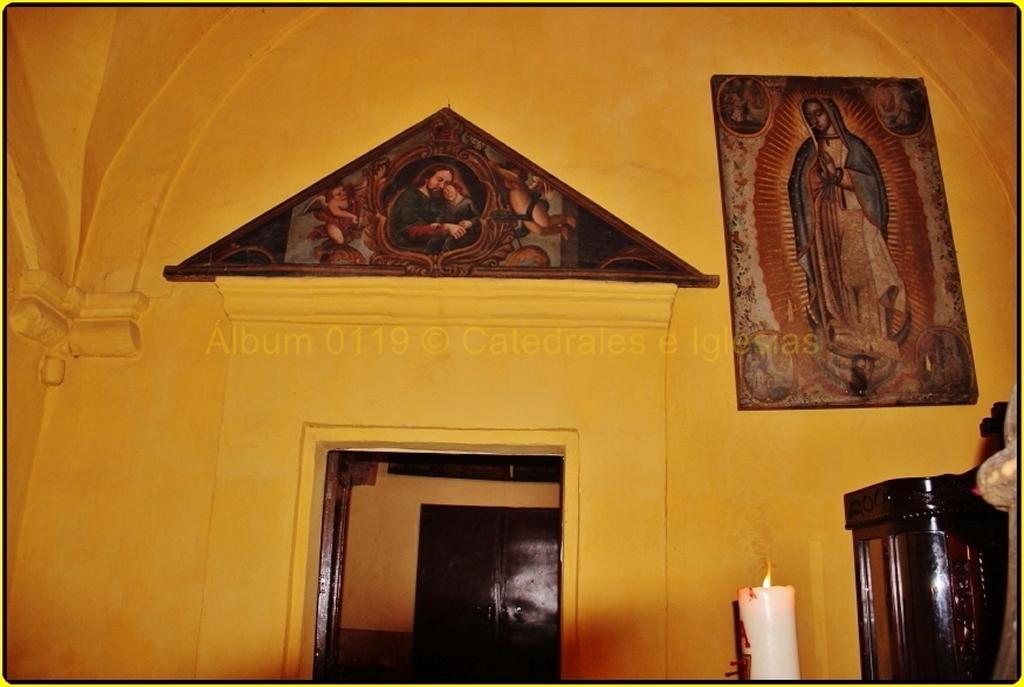Can you describe this image briefly? This picture shows an inner view of a room. We see couple of photo frames on the wall and a cupboard on the side and we see a burning candle. 